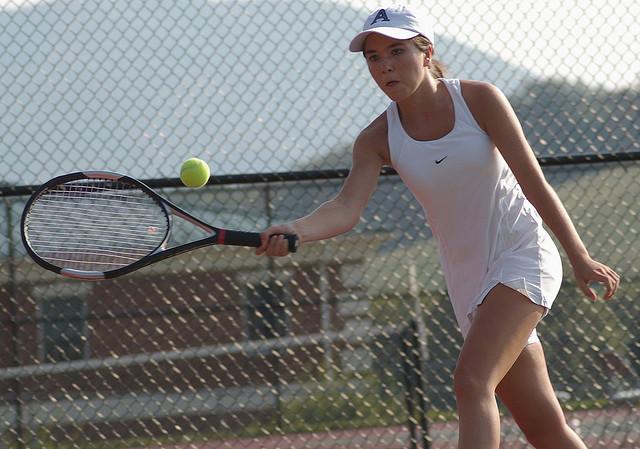Is anyone playing tennis in this photo?
Short answer required. Yes. Is it day or night?
Write a very short answer. Day. What kind of fence is behind the girl?
Answer briefly. Chain link. How many tennis balls do you see?
Be succinct. 1. What brand of clothing is her outfit?
Concise answer only. Nike. 